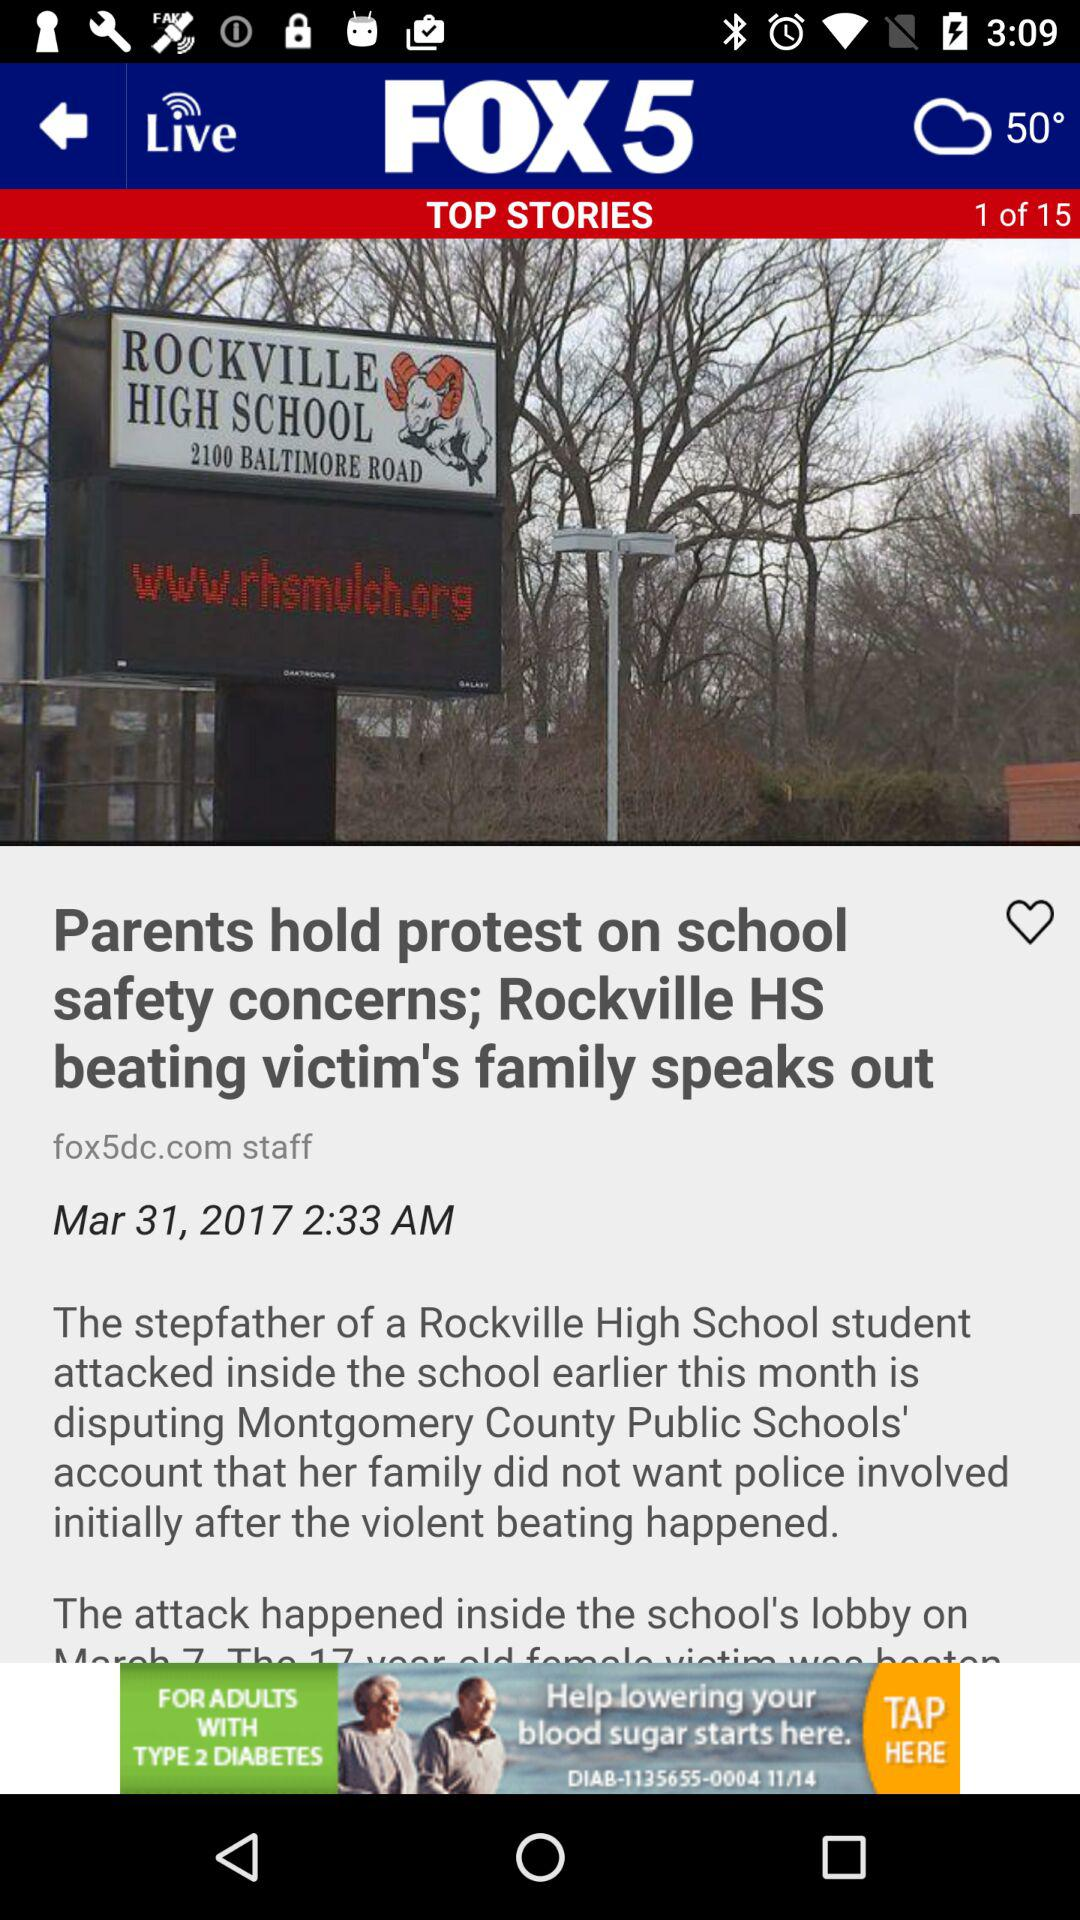When was the article published? The article was published on March 31st, 2017 at 2:33 AM. 